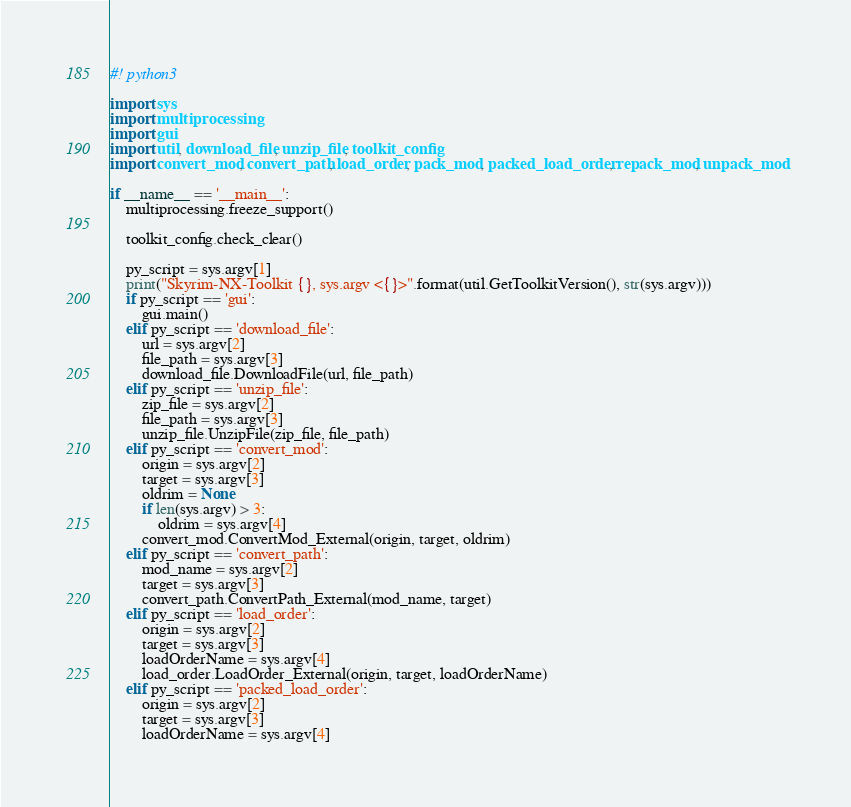<code> <loc_0><loc_0><loc_500><loc_500><_Python_>#! python3

import sys
import multiprocessing
import gui
import util, download_file, unzip_file, toolkit_config
import convert_mod, convert_path, load_order, pack_mod, packed_load_order, repack_mod, unpack_mod

if __name__ == '__main__':
	multiprocessing.freeze_support()

	toolkit_config.check_clear()

	py_script = sys.argv[1]
	print("Skyrim-NX-Toolkit {}, sys.argv <{}>".format(util.GetToolkitVersion(), str(sys.argv)))
	if py_script == 'gui':
		gui.main()
	elif py_script == 'download_file':
		url = sys.argv[2]
		file_path = sys.argv[3]
		download_file.DownloadFile(url, file_path)
	elif py_script == 'unzip_file':
		zip_file = sys.argv[2]
		file_path = sys.argv[3]
		unzip_file.UnzipFile(zip_file, file_path)
	elif py_script == 'convert_mod':
		origin = sys.argv[2]
		target = sys.argv[3]
		oldrim = None
		if len(sys.argv) > 3:
			oldrim = sys.argv[4]
		convert_mod.ConvertMod_External(origin, target, oldrim)
	elif py_script == 'convert_path':
		mod_name = sys.argv[2]
		target = sys.argv[3]
		convert_path.ConvertPath_External(mod_name, target)
	elif py_script == 'load_order':
		origin = sys.argv[2]
		target = sys.argv[3]
		loadOrderName = sys.argv[4]
		load_order.LoadOrder_External(origin, target, loadOrderName)
	elif py_script == 'packed_load_order':
		origin = sys.argv[2]
		target = sys.argv[3]
		loadOrderName = sys.argv[4]</code> 